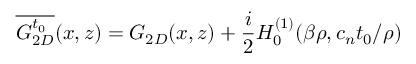<formula> <loc_0><loc_0><loc_500><loc_500>\overline { { G _ { 2 D } ^ { t _ { 0 } } } } ( x , z ) = G _ { 2 D } ( x , z ) + \frac { i } { 2 } H _ { 0 } ^ { ( 1 ) } ( \beta \rho , c _ { n } t _ { 0 } / \rho )</formula> 